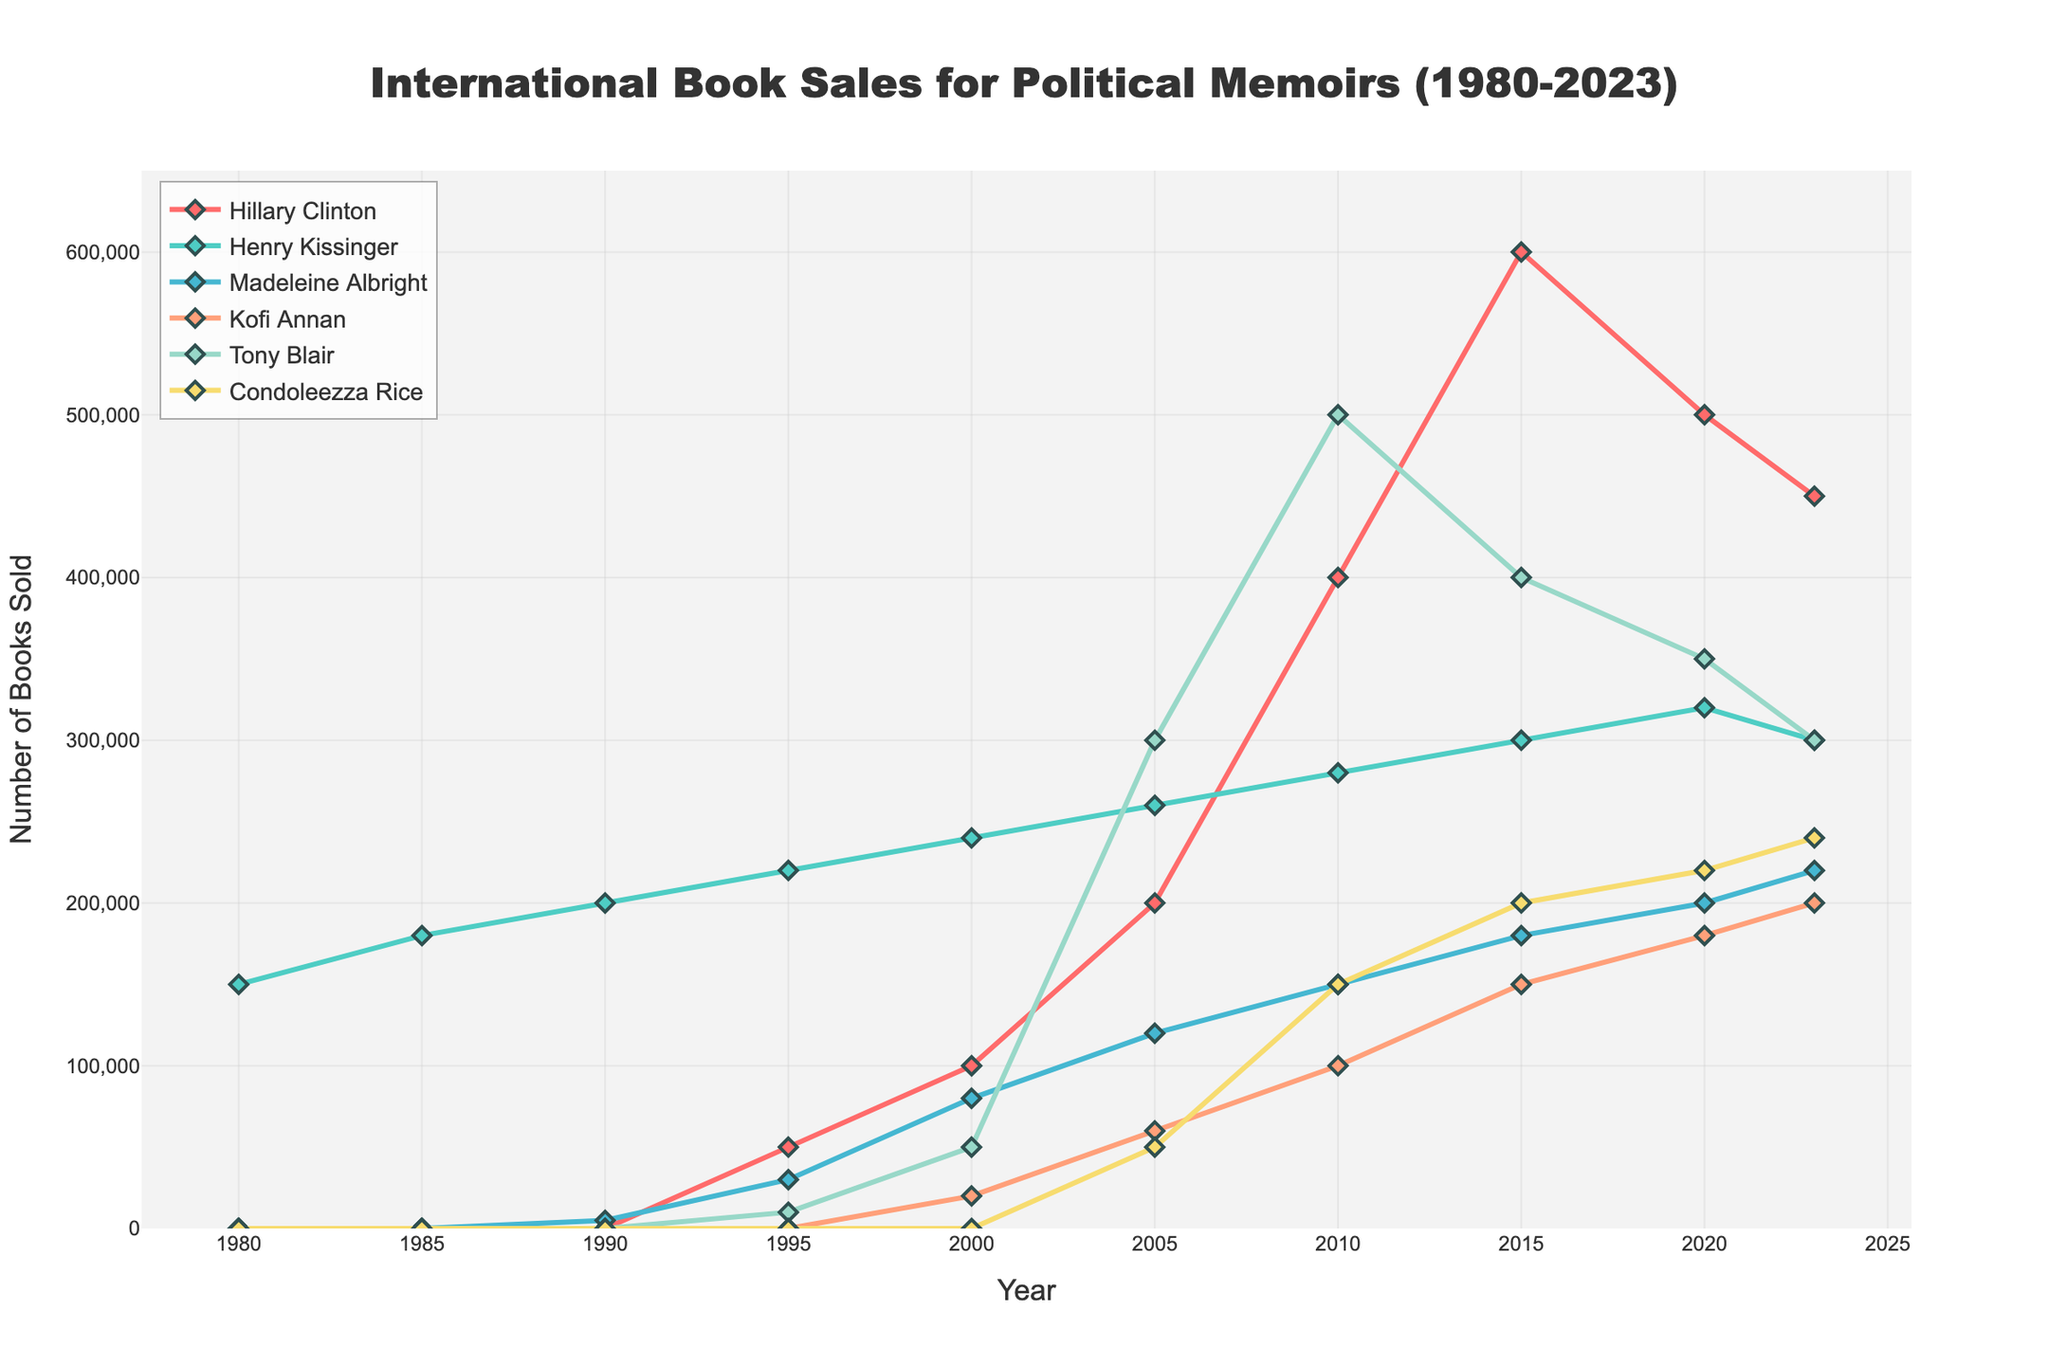What was the overall trend in book sales for Hillary Clinton from 2000 to 2023? From 2000 to 2010, Hillary Clinton's book sales increased from 100,000 to 400,000. They continued to rise, reaching 600,000 in 2015 but then declined to 500,000 in 2020, and further to 450,000 by 2023. The overall trend shows a rise followed by a decline.
Answer: Rise then decline Which author had the highest book sales in 2010? Observing the figure, Tony Blair had the highest book sales in 2010 with 500,000 books sold.
Answer: Tony Blair Compare the book sales of Henry Kissinger and Kofi Annan in 2020. Who sold more books? In 2020, Henry Kissinger sold 320,000 books and Kofi Annan sold 180,000 books. Comparing these values, Henry Kissinger sold more books.
Answer: Henry Kissinger What is the difference in book sales between Madeleine Albright and Condoleezza Rice in 2023? In 2023, Madeleine Albright sold 220,000 books and Condoleezza Rice sold 240,000 books. The difference is 240,000 - 220,000 = 20,000 books.
Answer: 20,000 books How did Tony Blair's book sales change from 2000 to 2005? Tony Blair's book sales increased from 50,000 in 2000 to 300,000 in 2005. The change is 300,000 - 50,000 = 250,000.
Answer: Increased by 250,000 What was the average number of books sold by Henry Kissinger from 1980 to 2023? To find the average, sum Henry Kissinger's book sales for each year: 150,000 + 180,000 + 200,000 + 220,000 + 240,000 + 260,000 + 280,000 + 300,000 + 320,000 + 300,000 = 2,450,000. Then divide by the number of years with data (10): 2,450,000 / 10 = 245,000.
Answer: 245,000 books Which author had the steepest increase in book sales between any two consecutive years, and what was the increase? Tony Blair had the steepest increase between 2000 and 2005, where his book sales rose from 50,000 to 300,000. The increase is 300,000 - 50,000 = 250,000.
Answer: Tony Blair; 250,000 How did the book sales for Kofi Annan evolve from 2010 to 2023? Kofi Annan's book sales increased steadily from 100,000 in 2010 to 150,000 in 2015, 180,000 in 2020, and reached 200,000 in 2023, showing a consistent upward trend.
Answer: Consistent upward trend Who had higher book sales in 1995, Henry Kissinger or Tony Blair? In 1995, Henry Kissinger sold 220,000 books while Tony Blair sold 10,000 books. Therefore, Henry Kissinger had higher book sales.
Answer: Henry Kissinger What were the combined book sales for all authors in 2015? Summing the book sales in 2015: Hillary Clinton (600,000), Henry Kissinger (300,000), Madeleine Albright (180,000), Kofi Annan (150,000), Tony Blair (400,000), and Condoleezza Rice (200,000), the total is 600,000 + 300,000 + 180,000 + 150,000 + 400,000 + 200,000 = 1,830,000.
Answer: 1,830,000 books 